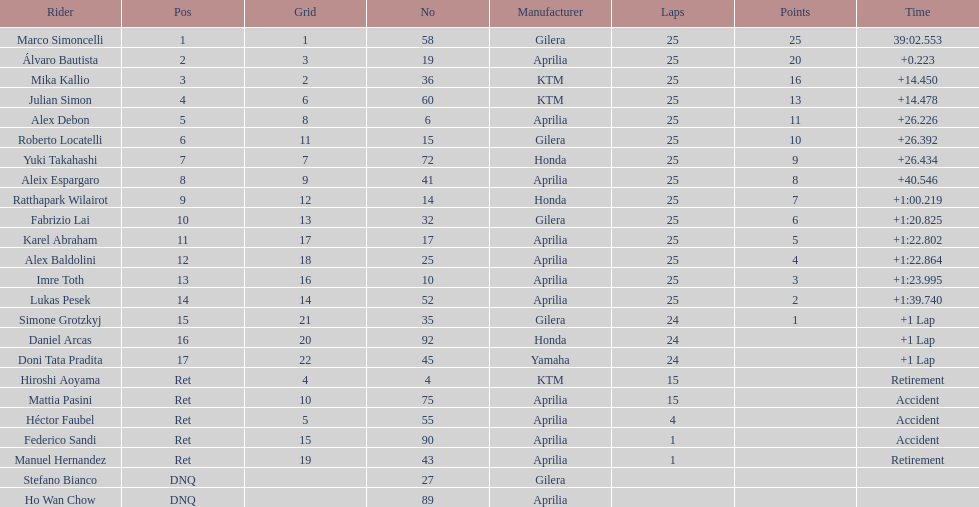What is the total number of rider? 24. 